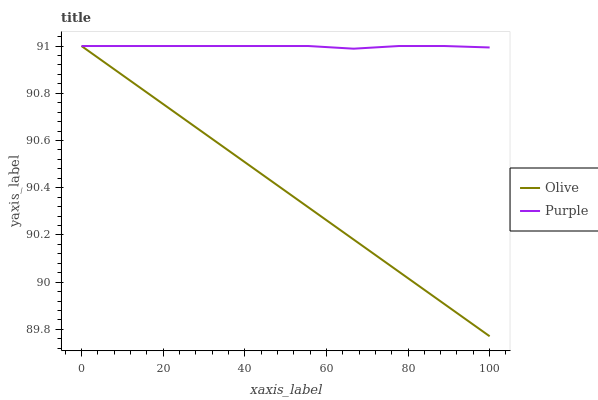Does Olive have the minimum area under the curve?
Answer yes or no. Yes. Does Purple have the maximum area under the curve?
Answer yes or no. Yes. Does Purple have the minimum area under the curve?
Answer yes or no. No. Is Olive the smoothest?
Answer yes or no. Yes. Is Purple the roughest?
Answer yes or no. Yes. Is Purple the smoothest?
Answer yes or no. No. Does Olive have the lowest value?
Answer yes or no. Yes. Does Purple have the lowest value?
Answer yes or no. No. Does Purple have the highest value?
Answer yes or no. Yes. Does Olive intersect Purple?
Answer yes or no. Yes. Is Olive less than Purple?
Answer yes or no. No. Is Olive greater than Purple?
Answer yes or no. No. 